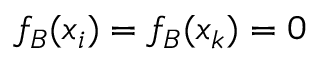<formula> <loc_0><loc_0><loc_500><loc_500>f _ { B } ( x _ { i } ) = f _ { B } ( x _ { k } ) = 0</formula> 